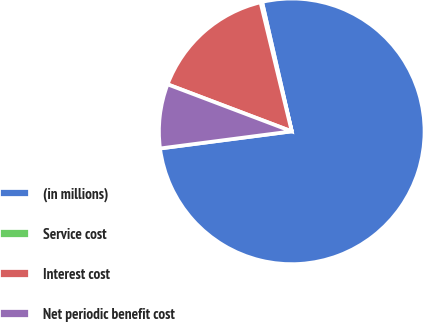Convert chart. <chart><loc_0><loc_0><loc_500><loc_500><pie_chart><fcel>(in millions)<fcel>Service cost<fcel>Interest cost<fcel>Net periodic benefit cost<nl><fcel>76.53%<fcel>0.19%<fcel>15.46%<fcel>7.82%<nl></chart> 